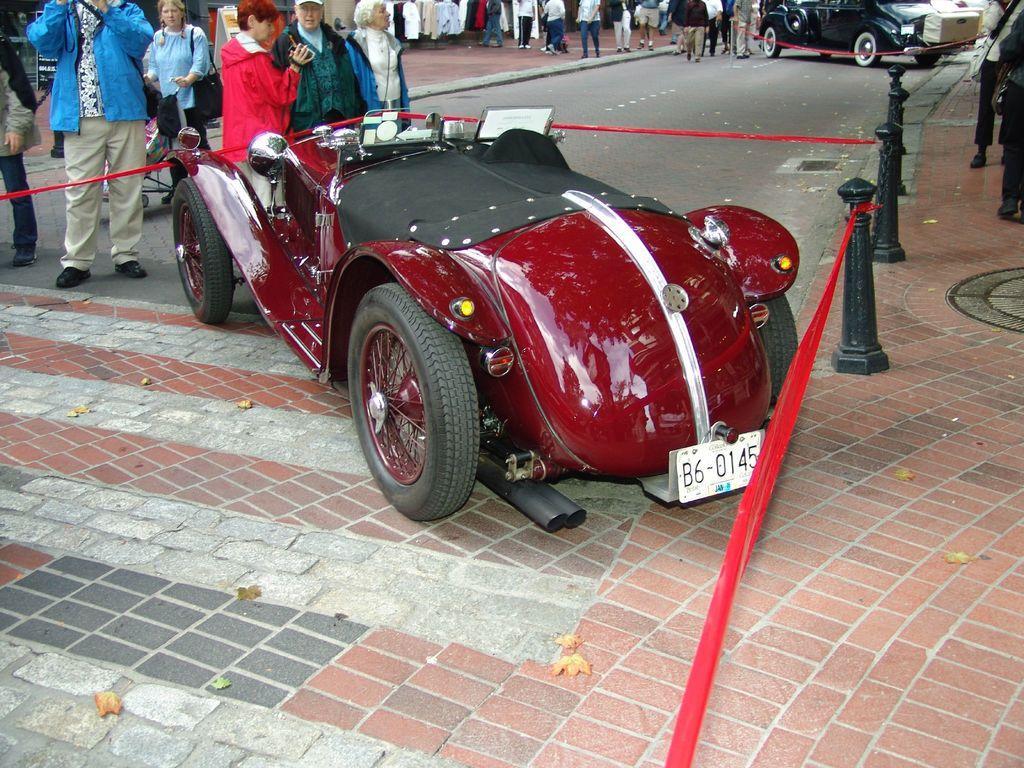Please provide a concise description of this image. In this image we can see a car placed on the surface. We can also see some poles tied with ribbons around it. On the backside we can see a group of people standing. In that a woman is holding a camera. We can also see a car on the road. 